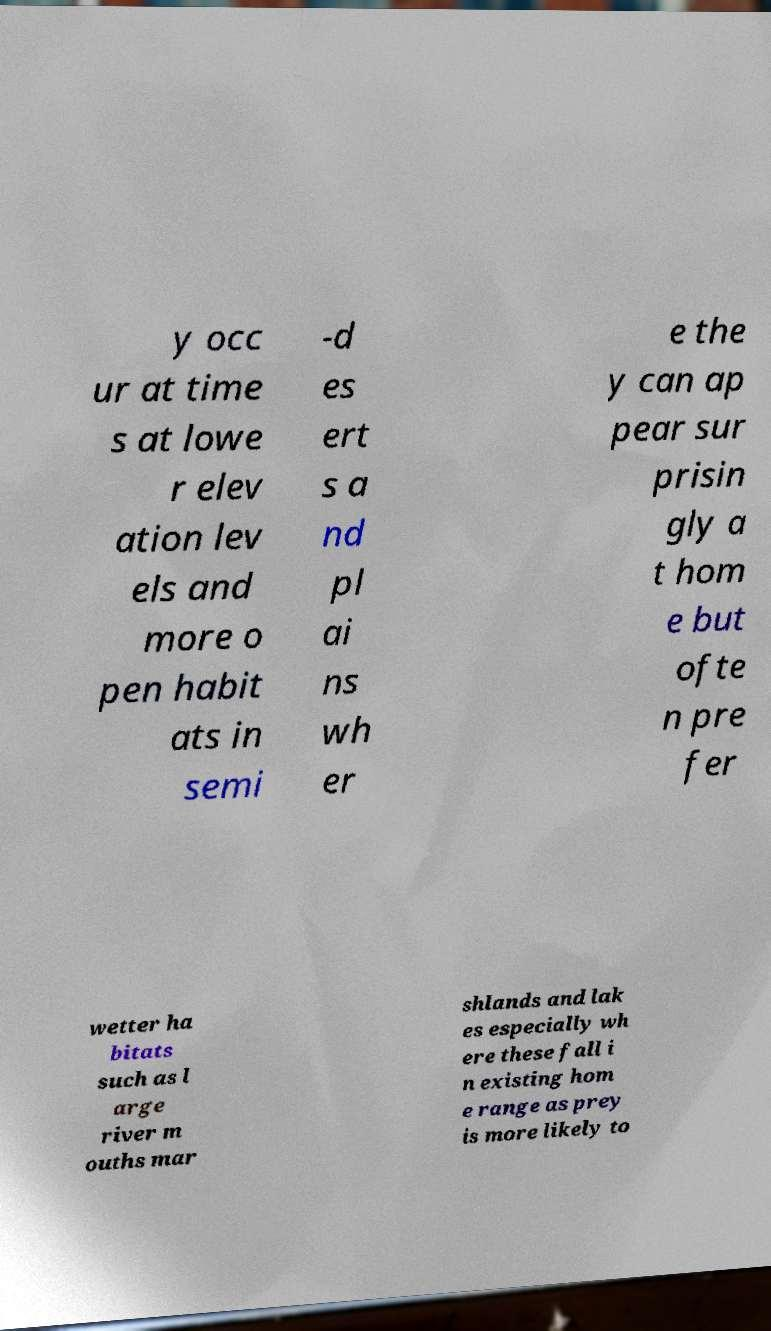Can you read and provide the text displayed in the image?This photo seems to have some interesting text. Can you extract and type it out for me? y occ ur at time s at lowe r elev ation lev els and more o pen habit ats in semi -d es ert s a nd pl ai ns wh er e the y can ap pear sur prisin gly a t hom e but ofte n pre fer wetter ha bitats such as l arge river m ouths mar shlands and lak es especially wh ere these fall i n existing hom e range as prey is more likely to 